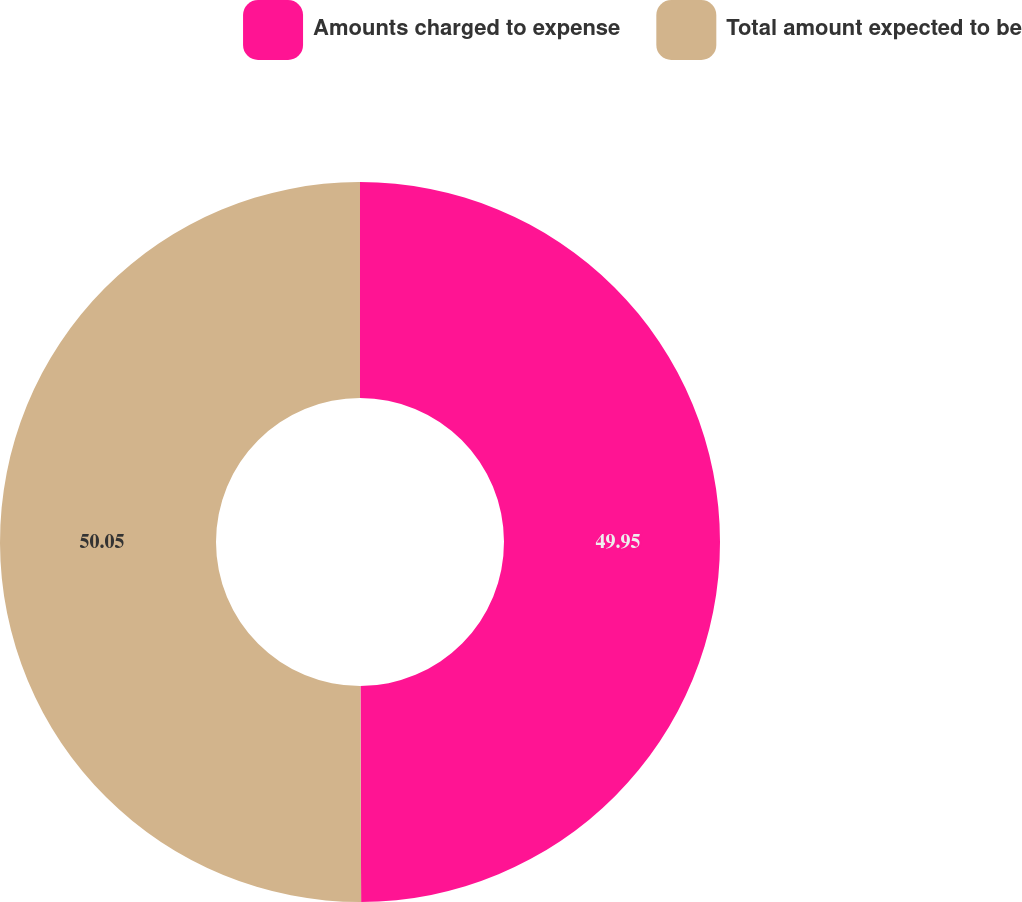Convert chart. <chart><loc_0><loc_0><loc_500><loc_500><pie_chart><fcel>Amounts charged to expense<fcel>Total amount expected to be<nl><fcel>49.95%<fcel>50.05%<nl></chart> 